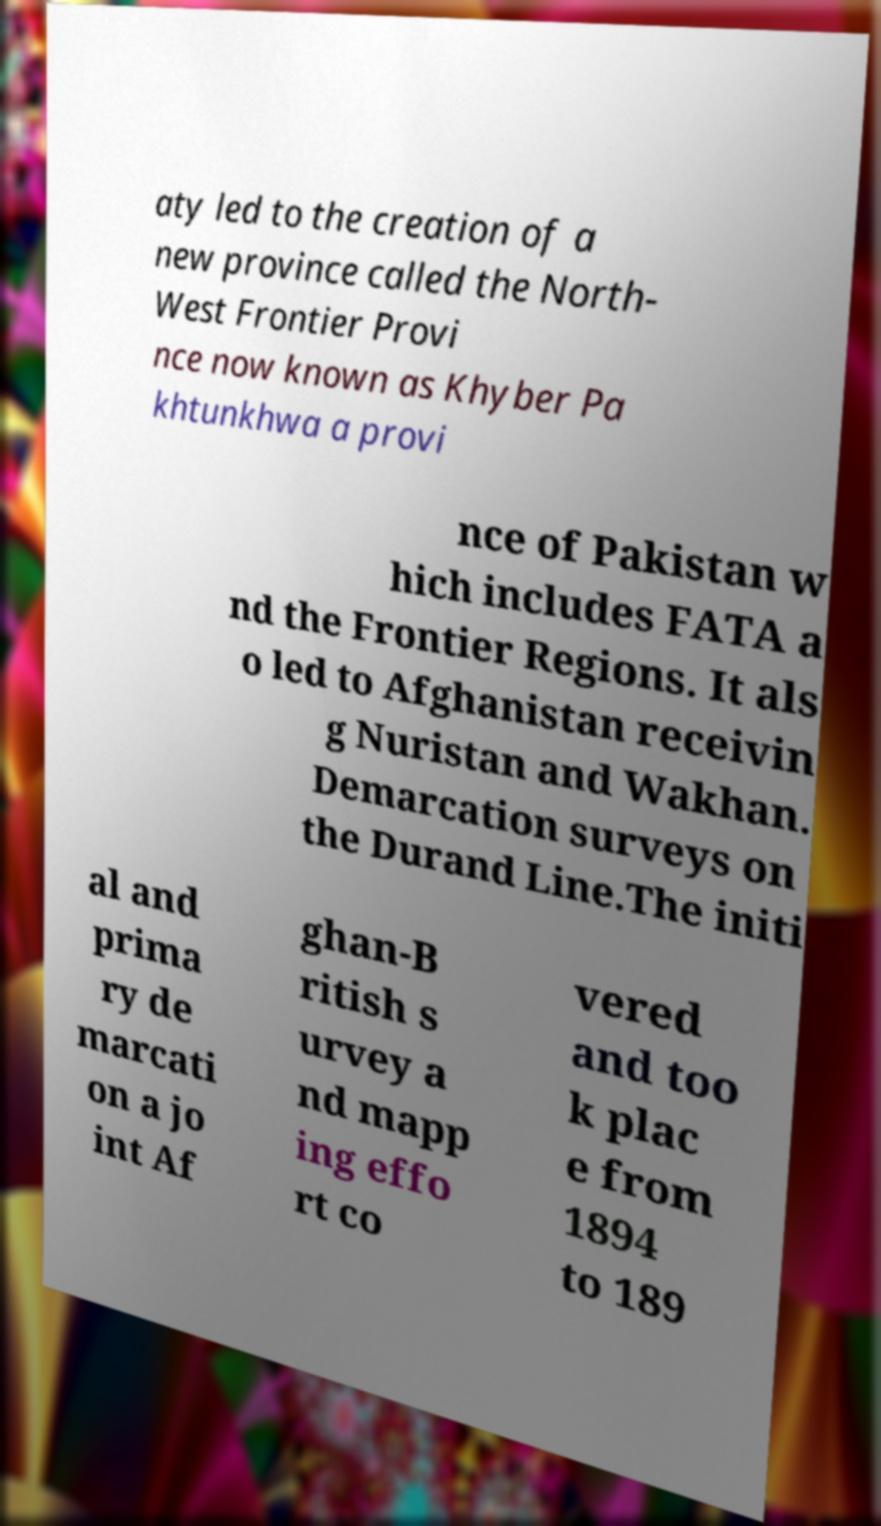There's text embedded in this image that I need extracted. Can you transcribe it verbatim? aty led to the creation of a new province called the North- West Frontier Provi nce now known as Khyber Pa khtunkhwa a provi nce of Pakistan w hich includes FATA a nd the Frontier Regions. It als o led to Afghanistan receivin g Nuristan and Wakhan. Demarcation surveys on the Durand Line.The initi al and prima ry de marcati on a jo int Af ghan-B ritish s urvey a nd mapp ing effo rt co vered and too k plac e from 1894 to 189 